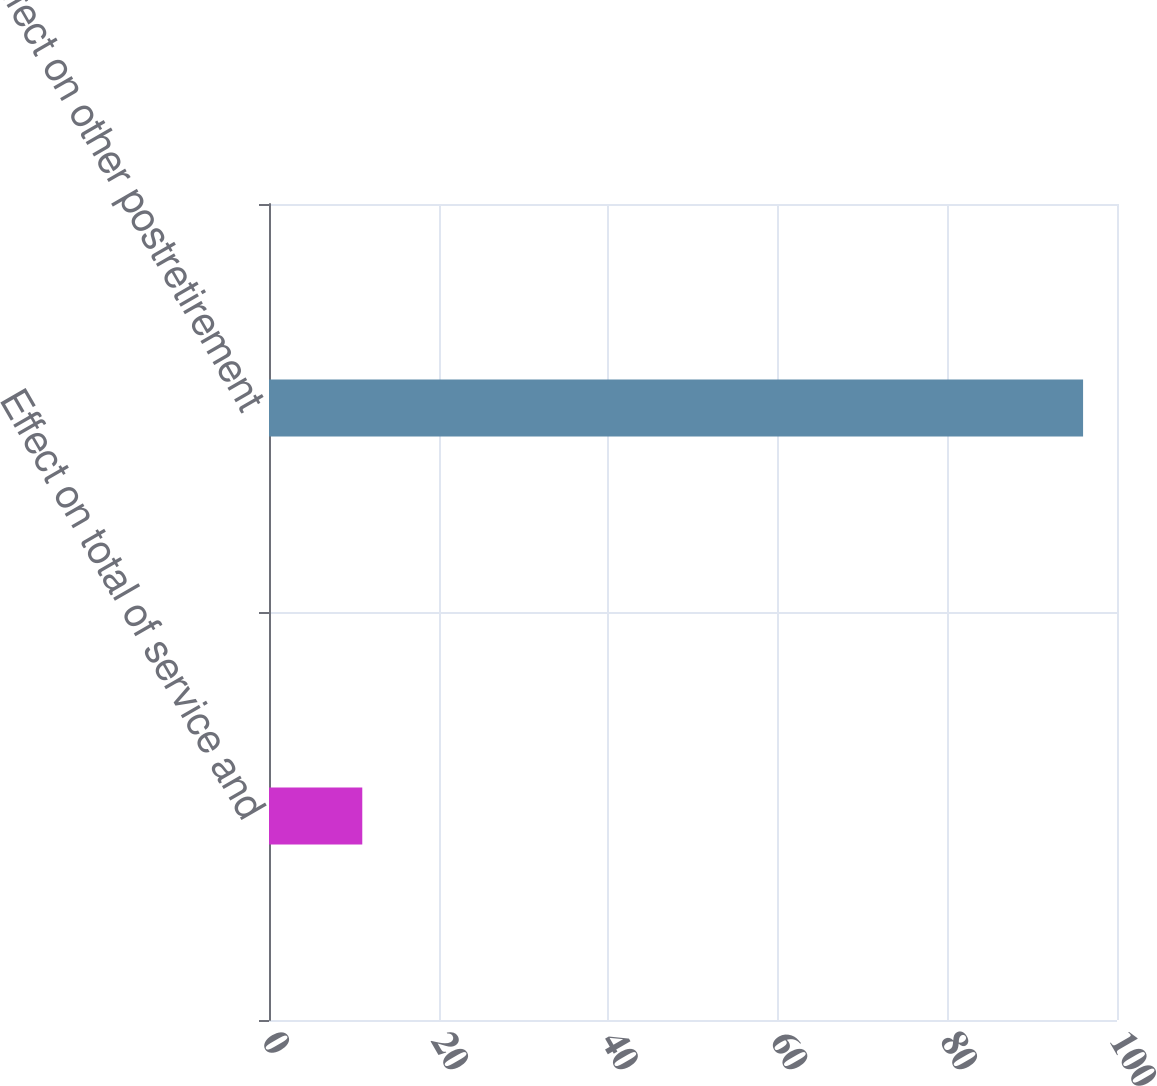<chart> <loc_0><loc_0><loc_500><loc_500><bar_chart><fcel>Effect on total of service and<fcel>Effect on other postretirement<nl><fcel>11<fcel>96<nl></chart> 